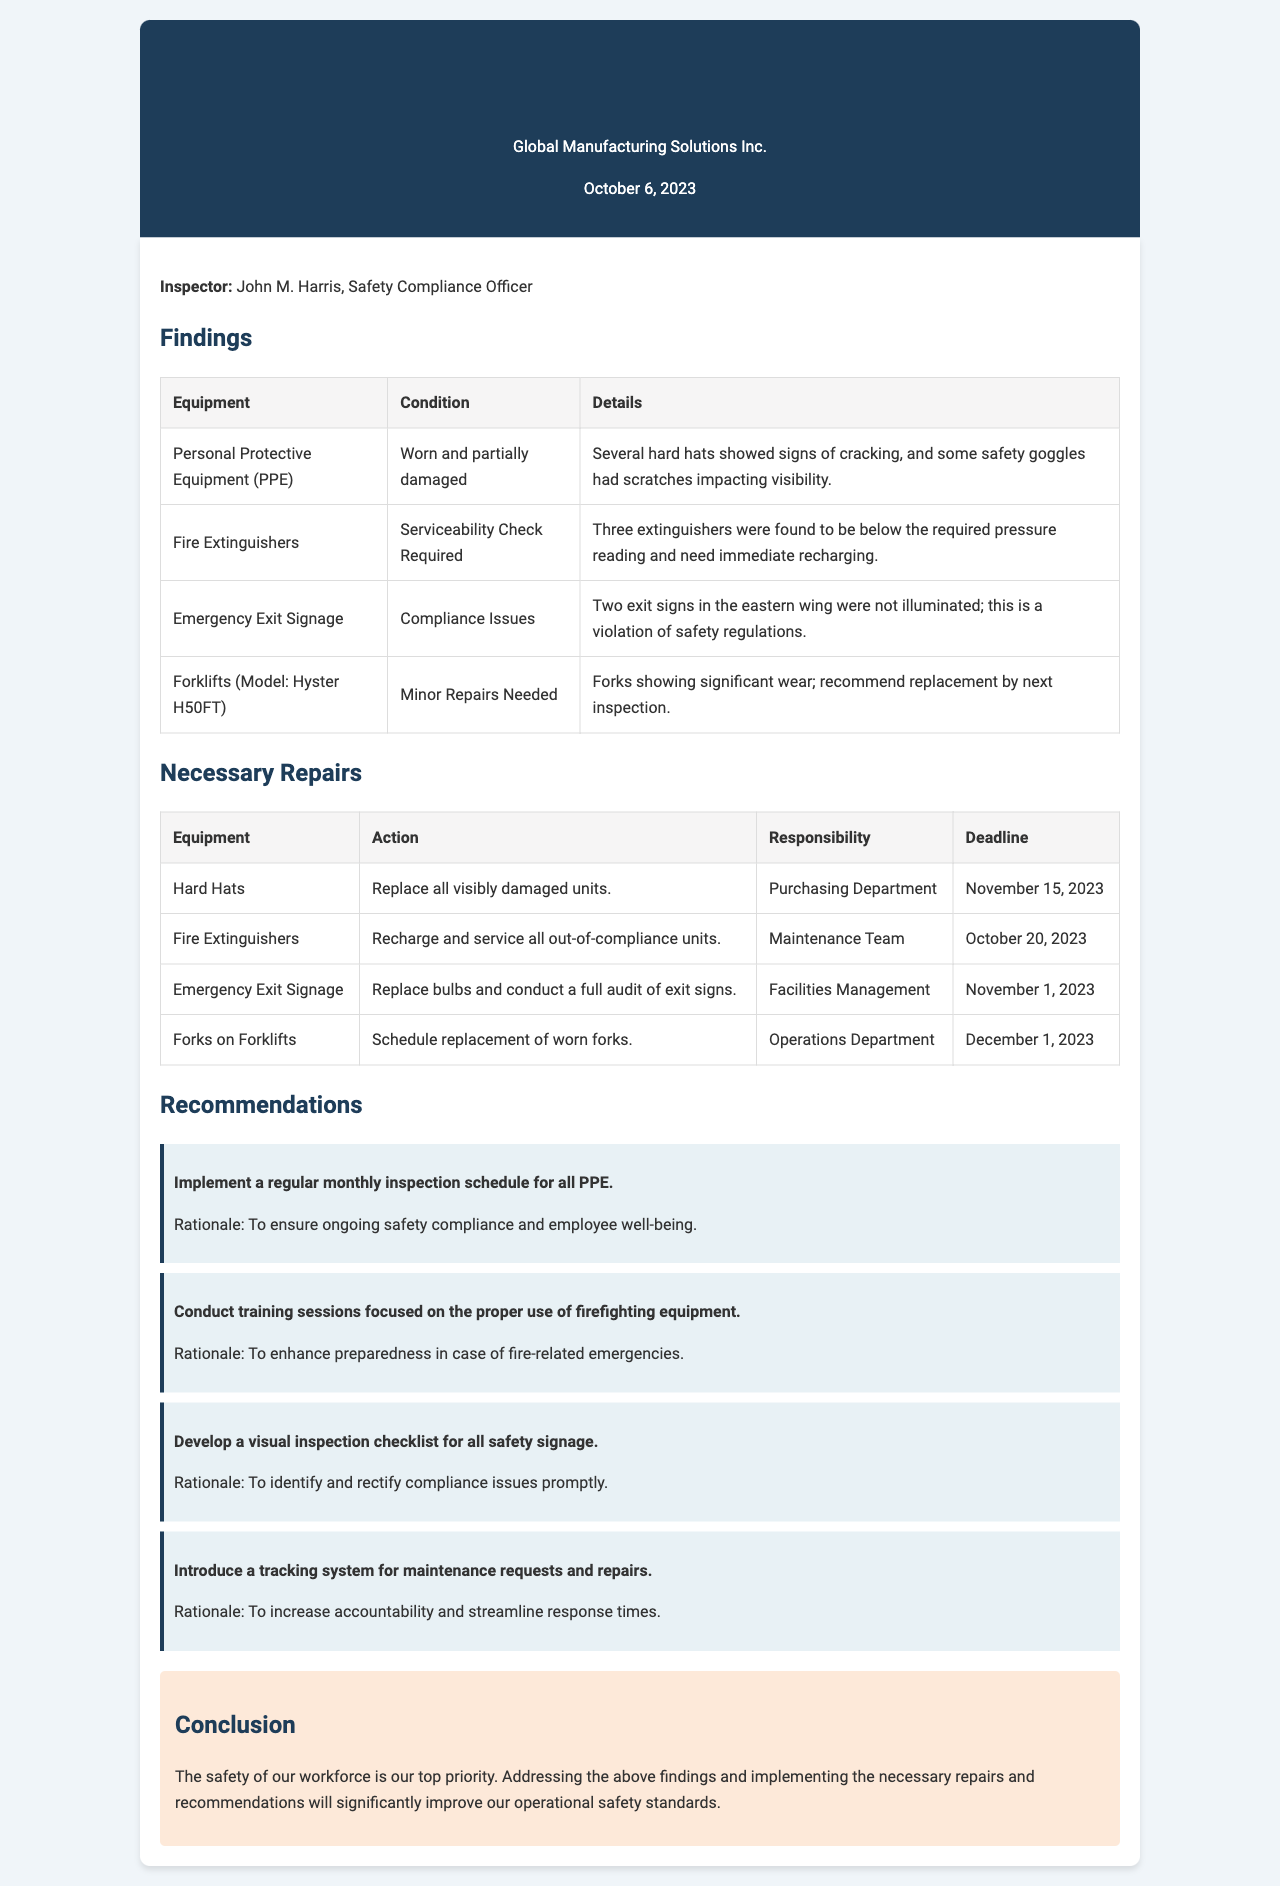What is the date of the report? The date of the report is stated in the header of the document.
Answer: October 6, 2023 Who conducted the inspection? The inspector's name is listed under the inspector section of the report.
Answer: John M. Harris What is the condition of the fire extinguishers? The condition of the fire extinguishers is found in the findings section labeled under the equipment.
Answer: Serviceability Check Required What action is required for hard hats? The necessary repairs for the hard hats are specified in the repairs table.
Answer: Replace all visibly damaged units What is the deadline for recharging fire extinguishers? The deadline for the action is mentioned in the necessary repairs section for fire extinguishers.
Answer: October 20, 2023 What is one recommendation for PPE? The recommendations section lists improvement suggestions for safety equipment.
Answer: Implement a regular monthly inspection schedule for all PPE Which department is responsible for replacing the forks on forklifts? The responsibility for the forks replacement is outlined in the necessary repairs table.
Answer: Operations Department What compliance issue was found regarding exit signage? The compliance issue is explained in the findings section about the exit signs.
Answer: Not illuminated What is the conclusion about workforce safety? The conclusion summarizes the overall priority regarding safety found in the conclusion section.
Answer: The safety of our workforce is our top priority 